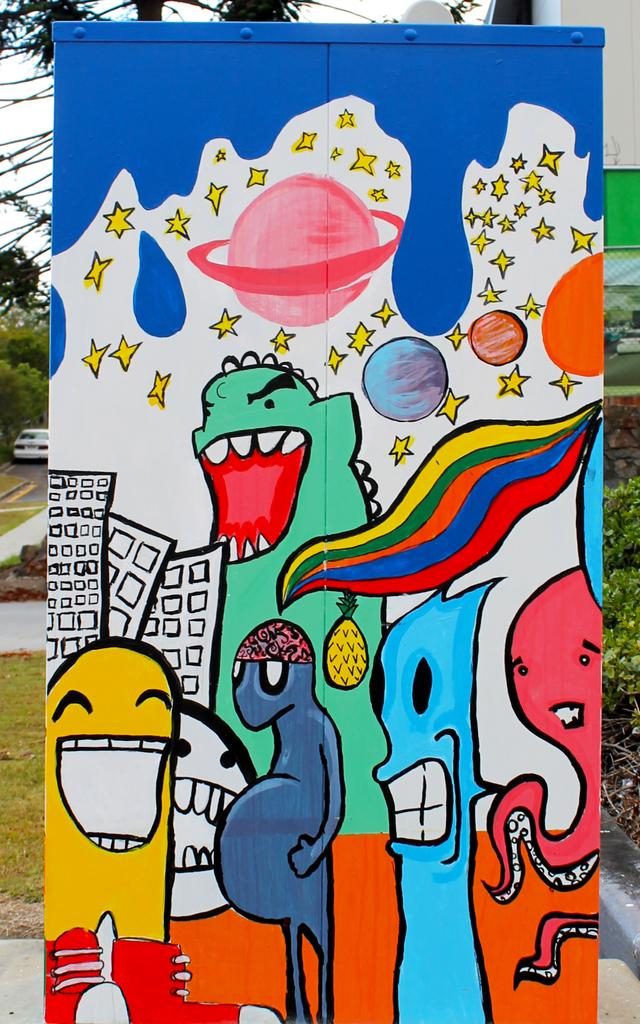What is hanging or displayed in the image? There is a banner with some painting on it in the image. What can be seen behind the banner? There is a building behind the banner. What type of natural elements are present in the image? There are trees, grass, and plants in the image. What is parked on the road in the image? There is a car parked on the road in the image. How many rabbits can be seen playing with a calculator in the image? There are no rabbits or calculators present in the image. What type of twig is used as a prop in the painting on the banner? There is no mention of a twig in the painting on the banner, and we cannot determine its contents from the image. 